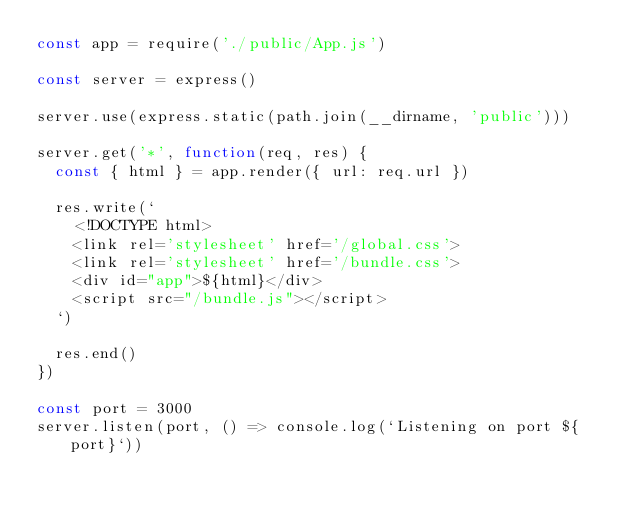<code> <loc_0><loc_0><loc_500><loc_500><_JavaScript_>const app = require('./public/App.js')

const server = express()

server.use(express.static(path.join(__dirname, 'public')))

server.get('*', function(req, res) {
  const { html } = app.render({ url: req.url })

  res.write(`
    <!DOCTYPE html>
    <link rel='stylesheet' href='/global.css'>
    <link rel='stylesheet' href='/bundle.css'>
    <div id="app">${html}</div>
    <script src="/bundle.js"></script>
  `)

  res.end()
})

const port = 3000
server.listen(port, () => console.log(`Listening on port ${port}`))</code> 